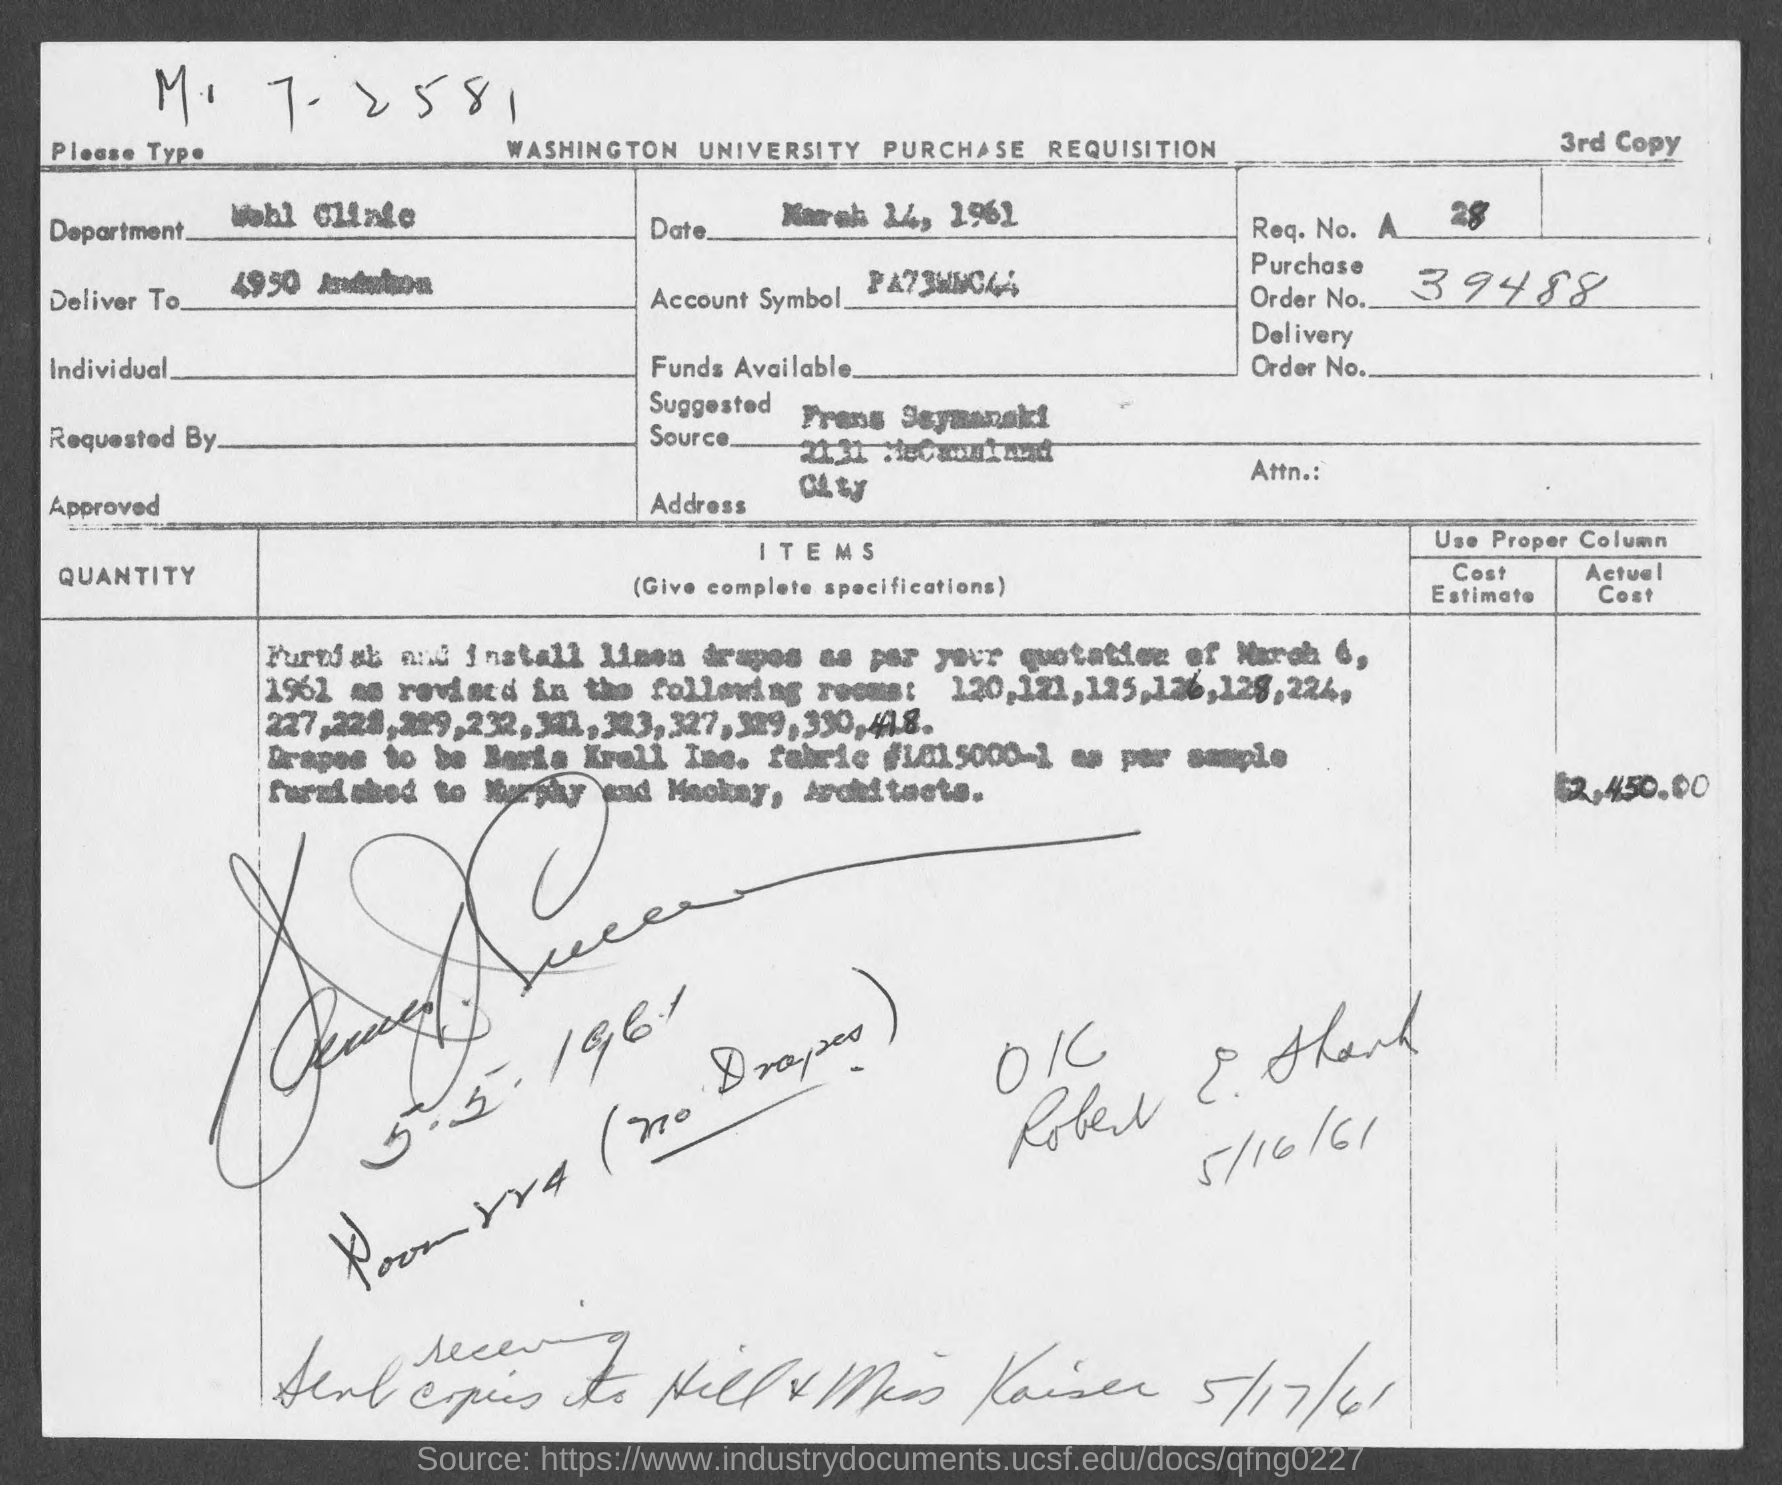What is the req. no. mentioned in the given page ?
Keep it short and to the point. A28. What is the order no. mentioned in the given page ?
Ensure brevity in your answer.  39488. What is the date mentioned in the given page ?
Your answer should be very brief. March 14, 1961. What is the name of the department mentioned in the given form ?
Offer a terse response. Wohl clinic. 